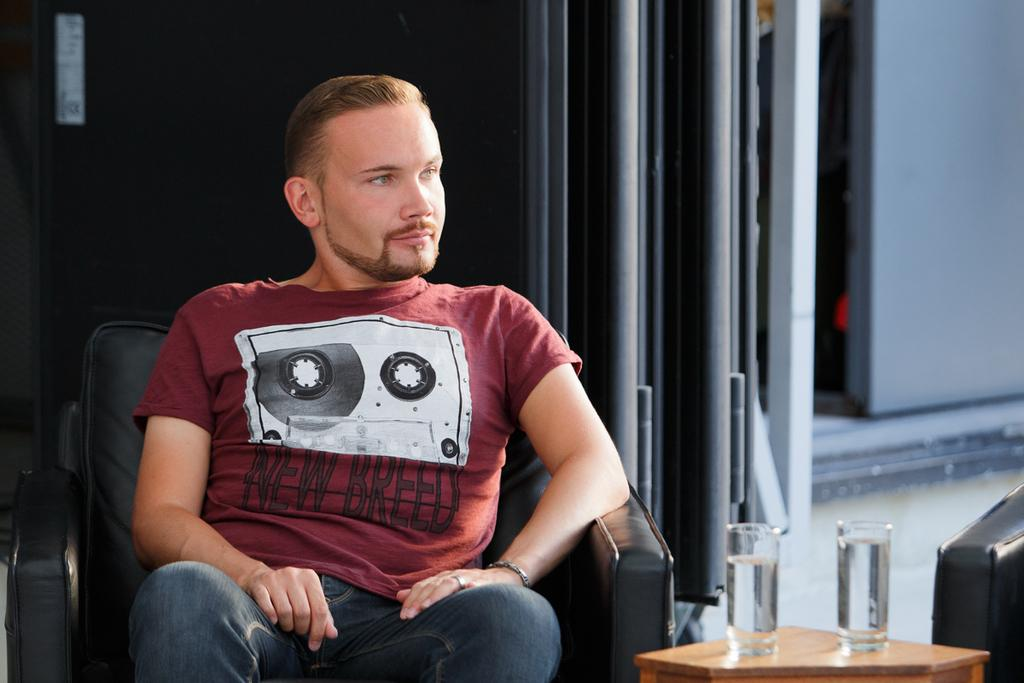What can be seen in the background of the image? There is a wall in the image. What is the man in the image doing? The man is sitting on a chair in the image. What is located near the man? There is a small table in the image. What objects are on the table? There are two glasses on the table. Is the man sitting on a prison chair in the image? There is no indication in the image that the chair is from a prison, and the chair's design cannot be determined from the image. Can you see a squirrel sitting on the man's shoulder in the image? There is no squirrel present in the image; it only features a man sitting on a chair, a small table, and two glasses on the table. 